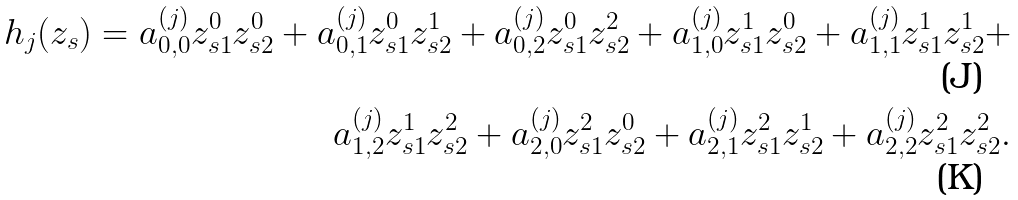Convert formula to latex. <formula><loc_0><loc_0><loc_500><loc_500>h _ { j } ( { z _ { s } } ) = a ^ { ( j ) } _ { 0 , 0 } z _ { s 1 } ^ { 0 } z _ { s 2 } ^ { 0 } + a ^ { ( j ) } _ { 0 , 1 } z _ { s 1 } ^ { 0 } z _ { s 2 } ^ { 1 } + a ^ { ( j ) } _ { 0 , 2 } z _ { s 1 } ^ { 0 } z _ { s 2 } ^ { 2 } + a ^ { ( j ) } _ { 1 , 0 } z _ { s 1 } ^ { 1 } z _ { s 2 } ^ { 0 } + a ^ { ( j ) } _ { 1 , 1 } z _ { s 1 } ^ { 1 } z _ { s 2 } ^ { 1 } + \\ a ^ { ( j ) } _ { 1 , 2 } z _ { s 1 } ^ { 1 } z _ { s 2 } ^ { 2 } + a ^ { ( j ) } _ { 2 , 0 } z _ { s 1 } ^ { 2 } z _ { s 2 } ^ { 0 } + a ^ { ( j ) } _ { 2 , 1 } z _ { s 1 } ^ { 2 } z _ { s 2 } ^ { 1 } + a ^ { ( j ) } _ { 2 , 2 } z _ { s 1 } ^ { 2 } z _ { s 2 } ^ { 2 } .</formula> 